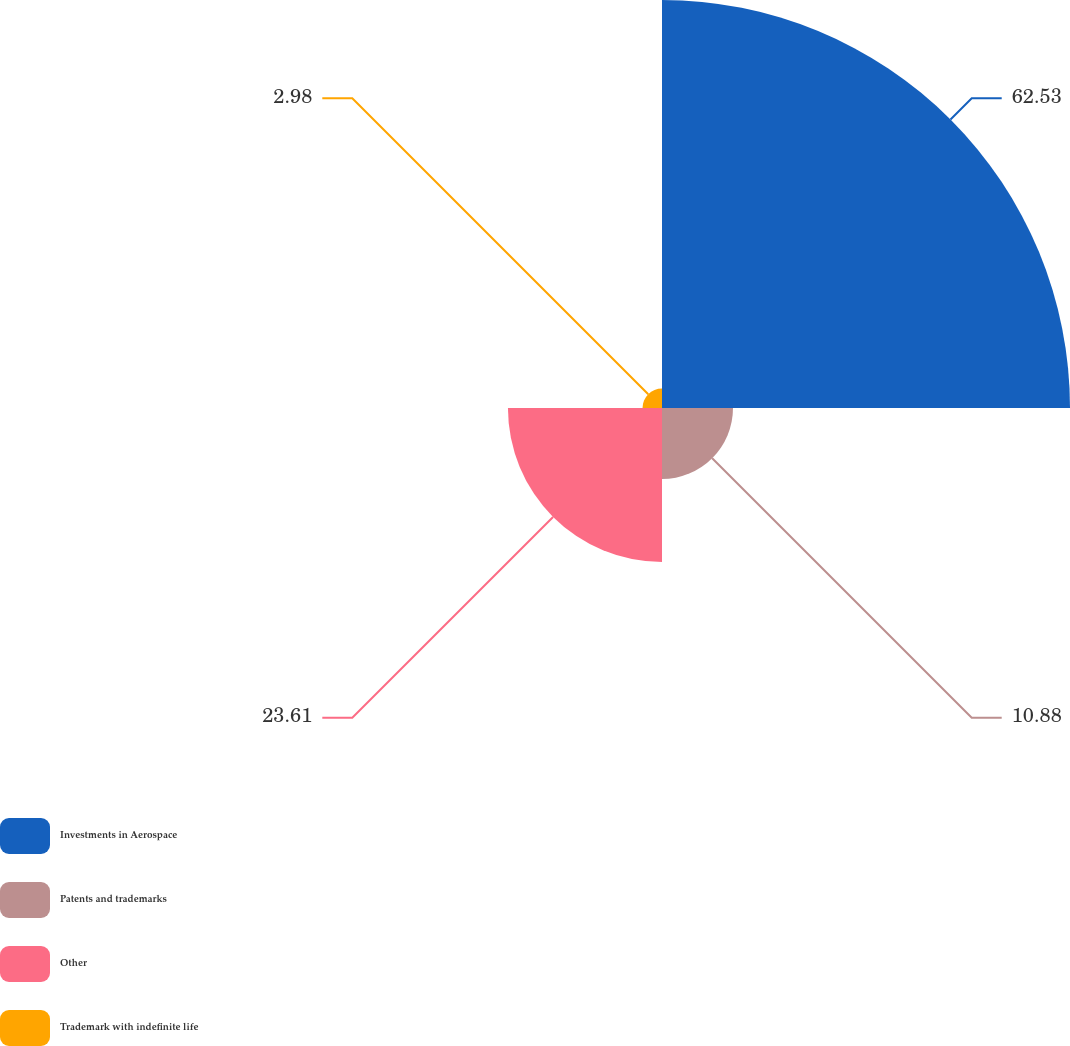Convert chart to OTSL. <chart><loc_0><loc_0><loc_500><loc_500><pie_chart><fcel>Investments in Aerospace<fcel>Patents and trademarks<fcel>Other<fcel>Trademark with indefinite life<nl><fcel>62.53%<fcel>10.88%<fcel>23.61%<fcel>2.98%<nl></chart> 